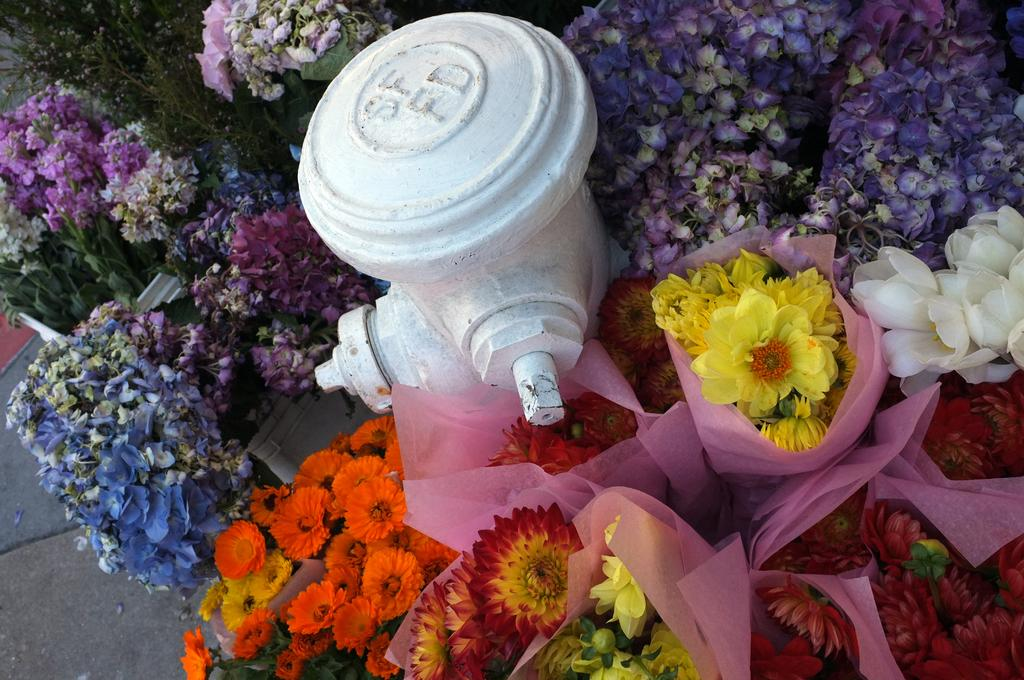What object is the main focus of the image? There is a fire hydrant in the image. What is the color of the fire hydrant? The fire hydrant is white in color. What else can be seen around the fire hydrant? There are flower bouquets around the fire hydrant. What type of weather can be seen through the window in the bedroom in the image? There is no window or bedroom present in the image; it only features a fire hydrant and flower bouquets. 